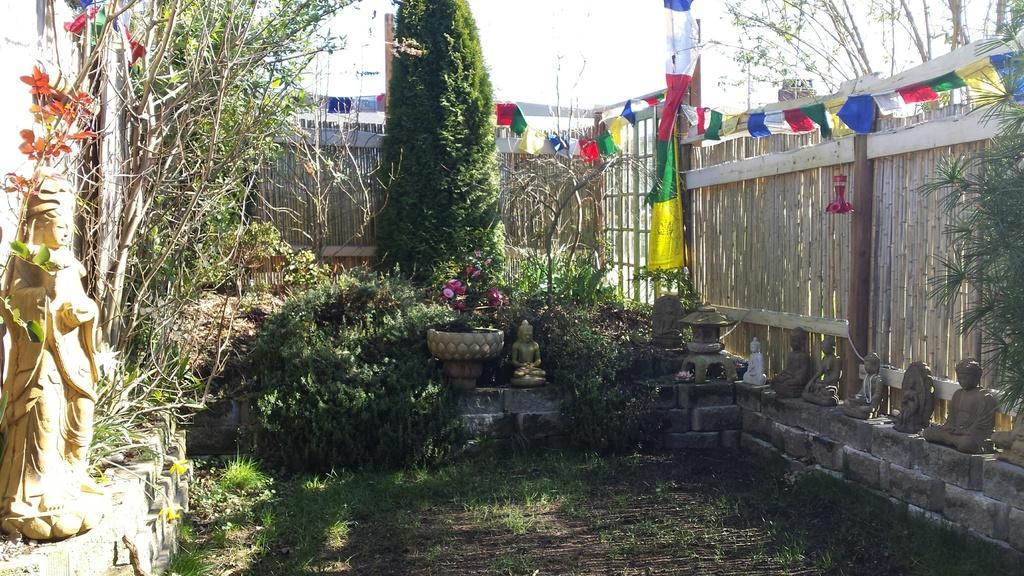Please provide a concise description of this image. This image consists of many trees and plants. In this image we can see many idols. At the bottom, there is grass on the ground. On the right, we can see a fencing made up of wood. At the top, there is sky. 